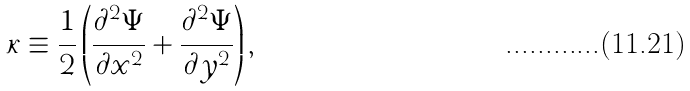Convert formula to latex. <formula><loc_0><loc_0><loc_500><loc_500>\kappa \equiv \frac { 1 } { 2 } \left ( \frac { \partial ^ { 2 } \Psi } { \partial x ^ { 2 } } + \frac { \partial ^ { 2 } \Psi } { \partial y ^ { 2 } } \right ) ,</formula> 